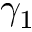Convert formula to latex. <formula><loc_0><loc_0><loc_500><loc_500>\gamma _ { 1 }</formula> 